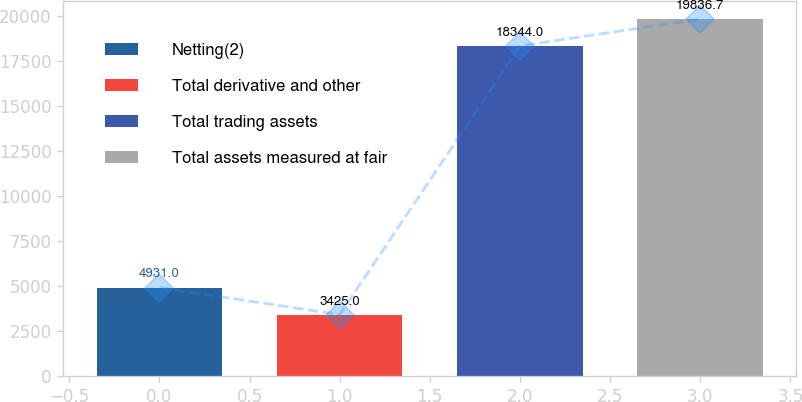Convert chart. <chart><loc_0><loc_0><loc_500><loc_500><bar_chart><fcel>Netting(2)<fcel>Total derivative and other<fcel>Total trading assets<fcel>Total assets measured at fair<nl><fcel>4931<fcel>3425<fcel>18344<fcel>19836.7<nl></chart> 